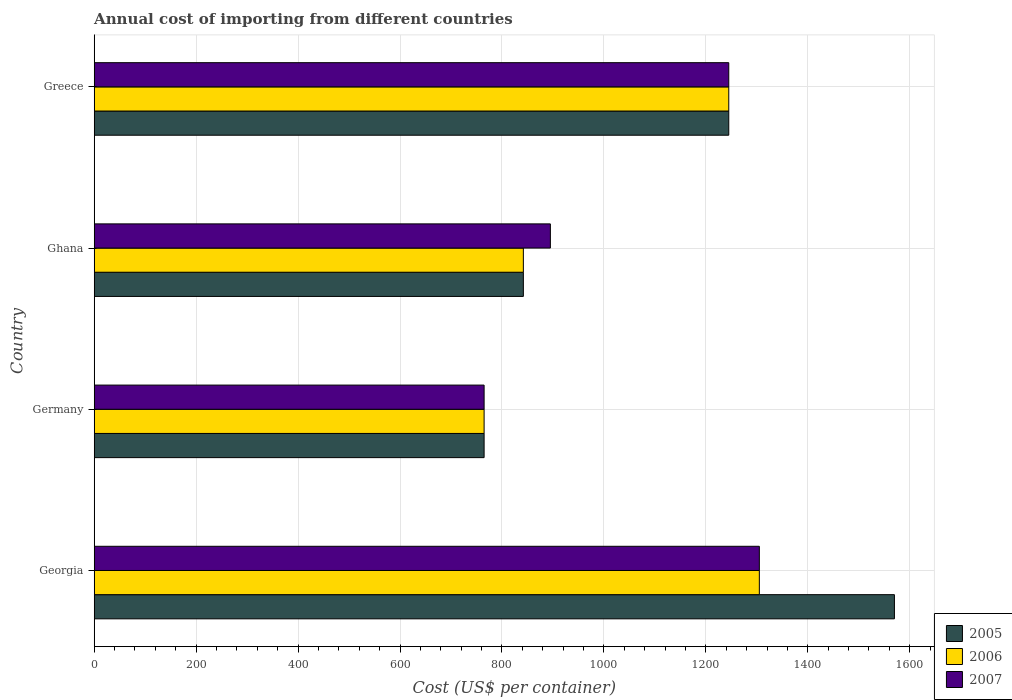How many different coloured bars are there?
Provide a short and direct response. 3. Are the number of bars per tick equal to the number of legend labels?
Give a very brief answer. Yes. Are the number of bars on each tick of the Y-axis equal?
Make the answer very short. Yes. How many bars are there on the 2nd tick from the top?
Offer a terse response. 3. How many bars are there on the 2nd tick from the bottom?
Your answer should be very brief. 3. What is the label of the 2nd group of bars from the top?
Your answer should be very brief. Ghana. In how many cases, is the number of bars for a given country not equal to the number of legend labels?
Your response must be concise. 0. What is the total annual cost of importing in 2007 in Georgia?
Provide a short and direct response. 1305. Across all countries, what is the maximum total annual cost of importing in 2006?
Offer a terse response. 1305. Across all countries, what is the minimum total annual cost of importing in 2006?
Your answer should be very brief. 765. In which country was the total annual cost of importing in 2005 maximum?
Your answer should be very brief. Georgia. What is the total total annual cost of importing in 2007 in the graph?
Ensure brevity in your answer.  4210. What is the difference between the total annual cost of importing in 2006 in Germany and that in Ghana?
Ensure brevity in your answer.  -77. What is the difference between the total annual cost of importing in 2007 in Greece and the total annual cost of importing in 2005 in Ghana?
Offer a terse response. 403. What is the average total annual cost of importing in 2005 per country?
Offer a very short reply. 1105.5. What is the difference between the total annual cost of importing in 2007 and total annual cost of importing in 2005 in Germany?
Offer a terse response. 0. What is the ratio of the total annual cost of importing in 2005 in Georgia to that in Ghana?
Offer a very short reply. 1.86. Is the difference between the total annual cost of importing in 2007 in Germany and Ghana greater than the difference between the total annual cost of importing in 2005 in Germany and Ghana?
Provide a succinct answer. No. What is the difference between the highest and the lowest total annual cost of importing in 2007?
Provide a succinct answer. 540. In how many countries, is the total annual cost of importing in 2007 greater than the average total annual cost of importing in 2007 taken over all countries?
Your answer should be very brief. 2. Is it the case that in every country, the sum of the total annual cost of importing in 2007 and total annual cost of importing in 2005 is greater than the total annual cost of importing in 2006?
Offer a terse response. Yes. Are all the bars in the graph horizontal?
Your answer should be very brief. Yes. Are the values on the major ticks of X-axis written in scientific E-notation?
Make the answer very short. No. Does the graph contain grids?
Your response must be concise. Yes. Where does the legend appear in the graph?
Provide a short and direct response. Bottom right. What is the title of the graph?
Your answer should be very brief. Annual cost of importing from different countries. What is the label or title of the X-axis?
Offer a terse response. Cost (US$ per container). What is the Cost (US$ per container) of 2005 in Georgia?
Give a very brief answer. 1570. What is the Cost (US$ per container) in 2006 in Georgia?
Ensure brevity in your answer.  1305. What is the Cost (US$ per container) of 2007 in Georgia?
Provide a short and direct response. 1305. What is the Cost (US$ per container) of 2005 in Germany?
Ensure brevity in your answer.  765. What is the Cost (US$ per container) in 2006 in Germany?
Give a very brief answer. 765. What is the Cost (US$ per container) in 2007 in Germany?
Your response must be concise. 765. What is the Cost (US$ per container) in 2005 in Ghana?
Make the answer very short. 842. What is the Cost (US$ per container) in 2006 in Ghana?
Your answer should be very brief. 842. What is the Cost (US$ per container) in 2007 in Ghana?
Make the answer very short. 895. What is the Cost (US$ per container) of 2005 in Greece?
Provide a short and direct response. 1245. What is the Cost (US$ per container) of 2006 in Greece?
Give a very brief answer. 1245. What is the Cost (US$ per container) in 2007 in Greece?
Keep it short and to the point. 1245. Across all countries, what is the maximum Cost (US$ per container) in 2005?
Offer a terse response. 1570. Across all countries, what is the maximum Cost (US$ per container) in 2006?
Your answer should be very brief. 1305. Across all countries, what is the maximum Cost (US$ per container) of 2007?
Offer a very short reply. 1305. Across all countries, what is the minimum Cost (US$ per container) in 2005?
Give a very brief answer. 765. Across all countries, what is the minimum Cost (US$ per container) in 2006?
Provide a short and direct response. 765. Across all countries, what is the minimum Cost (US$ per container) in 2007?
Ensure brevity in your answer.  765. What is the total Cost (US$ per container) in 2005 in the graph?
Your answer should be very brief. 4422. What is the total Cost (US$ per container) of 2006 in the graph?
Give a very brief answer. 4157. What is the total Cost (US$ per container) in 2007 in the graph?
Offer a terse response. 4210. What is the difference between the Cost (US$ per container) of 2005 in Georgia and that in Germany?
Offer a very short reply. 805. What is the difference between the Cost (US$ per container) of 2006 in Georgia and that in Germany?
Make the answer very short. 540. What is the difference between the Cost (US$ per container) in 2007 in Georgia and that in Germany?
Give a very brief answer. 540. What is the difference between the Cost (US$ per container) in 2005 in Georgia and that in Ghana?
Your response must be concise. 728. What is the difference between the Cost (US$ per container) in 2006 in Georgia and that in Ghana?
Keep it short and to the point. 463. What is the difference between the Cost (US$ per container) in 2007 in Georgia and that in Ghana?
Provide a short and direct response. 410. What is the difference between the Cost (US$ per container) of 2005 in Georgia and that in Greece?
Your answer should be very brief. 325. What is the difference between the Cost (US$ per container) in 2005 in Germany and that in Ghana?
Ensure brevity in your answer.  -77. What is the difference between the Cost (US$ per container) of 2006 in Germany and that in Ghana?
Provide a succinct answer. -77. What is the difference between the Cost (US$ per container) in 2007 in Germany and that in Ghana?
Ensure brevity in your answer.  -130. What is the difference between the Cost (US$ per container) of 2005 in Germany and that in Greece?
Your response must be concise. -480. What is the difference between the Cost (US$ per container) of 2006 in Germany and that in Greece?
Your response must be concise. -480. What is the difference between the Cost (US$ per container) in 2007 in Germany and that in Greece?
Offer a terse response. -480. What is the difference between the Cost (US$ per container) in 2005 in Ghana and that in Greece?
Give a very brief answer. -403. What is the difference between the Cost (US$ per container) in 2006 in Ghana and that in Greece?
Give a very brief answer. -403. What is the difference between the Cost (US$ per container) of 2007 in Ghana and that in Greece?
Provide a short and direct response. -350. What is the difference between the Cost (US$ per container) of 2005 in Georgia and the Cost (US$ per container) of 2006 in Germany?
Your answer should be very brief. 805. What is the difference between the Cost (US$ per container) of 2005 in Georgia and the Cost (US$ per container) of 2007 in Germany?
Offer a terse response. 805. What is the difference between the Cost (US$ per container) of 2006 in Georgia and the Cost (US$ per container) of 2007 in Germany?
Provide a short and direct response. 540. What is the difference between the Cost (US$ per container) of 2005 in Georgia and the Cost (US$ per container) of 2006 in Ghana?
Offer a terse response. 728. What is the difference between the Cost (US$ per container) of 2005 in Georgia and the Cost (US$ per container) of 2007 in Ghana?
Your answer should be very brief. 675. What is the difference between the Cost (US$ per container) of 2006 in Georgia and the Cost (US$ per container) of 2007 in Ghana?
Your response must be concise. 410. What is the difference between the Cost (US$ per container) of 2005 in Georgia and the Cost (US$ per container) of 2006 in Greece?
Your response must be concise. 325. What is the difference between the Cost (US$ per container) of 2005 in Georgia and the Cost (US$ per container) of 2007 in Greece?
Your answer should be very brief. 325. What is the difference between the Cost (US$ per container) in 2005 in Germany and the Cost (US$ per container) in 2006 in Ghana?
Ensure brevity in your answer.  -77. What is the difference between the Cost (US$ per container) of 2005 in Germany and the Cost (US$ per container) of 2007 in Ghana?
Provide a short and direct response. -130. What is the difference between the Cost (US$ per container) in 2006 in Germany and the Cost (US$ per container) in 2007 in Ghana?
Ensure brevity in your answer.  -130. What is the difference between the Cost (US$ per container) in 2005 in Germany and the Cost (US$ per container) in 2006 in Greece?
Offer a terse response. -480. What is the difference between the Cost (US$ per container) in 2005 in Germany and the Cost (US$ per container) in 2007 in Greece?
Your answer should be compact. -480. What is the difference between the Cost (US$ per container) of 2006 in Germany and the Cost (US$ per container) of 2007 in Greece?
Keep it short and to the point. -480. What is the difference between the Cost (US$ per container) in 2005 in Ghana and the Cost (US$ per container) in 2006 in Greece?
Offer a very short reply. -403. What is the difference between the Cost (US$ per container) in 2005 in Ghana and the Cost (US$ per container) in 2007 in Greece?
Offer a terse response. -403. What is the difference between the Cost (US$ per container) of 2006 in Ghana and the Cost (US$ per container) of 2007 in Greece?
Offer a terse response. -403. What is the average Cost (US$ per container) in 2005 per country?
Keep it short and to the point. 1105.5. What is the average Cost (US$ per container) in 2006 per country?
Keep it short and to the point. 1039.25. What is the average Cost (US$ per container) of 2007 per country?
Provide a short and direct response. 1052.5. What is the difference between the Cost (US$ per container) in 2005 and Cost (US$ per container) in 2006 in Georgia?
Offer a very short reply. 265. What is the difference between the Cost (US$ per container) of 2005 and Cost (US$ per container) of 2007 in Georgia?
Ensure brevity in your answer.  265. What is the difference between the Cost (US$ per container) in 2006 and Cost (US$ per container) in 2007 in Georgia?
Your response must be concise. 0. What is the difference between the Cost (US$ per container) in 2005 and Cost (US$ per container) in 2006 in Germany?
Your response must be concise. 0. What is the difference between the Cost (US$ per container) of 2005 and Cost (US$ per container) of 2007 in Germany?
Make the answer very short. 0. What is the difference between the Cost (US$ per container) in 2006 and Cost (US$ per container) in 2007 in Germany?
Provide a short and direct response. 0. What is the difference between the Cost (US$ per container) in 2005 and Cost (US$ per container) in 2007 in Ghana?
Offer a very short reply. -53. What is the difference between the Cost (US$ per container) of 2006 and Cost (US$ per container) of 2007 in Ghana?
Make the answer very short. -53. What is the difference between the Cost (US$ per container) in 2005 and Cost (US$ per container) in 2006 in Greece?
Your response must be concise. 0. What is the difference between the Cost (US$ per container) in 2005 and Cost (US$ per container) in 2007 in Greece?
Ensure brevity in your answer.  0. What is the ratio of the Cost (US$ per container) of 2005 in Georgia to that in Germany?
Make the answer very short. 2.05. What is the ratio of the Cost (US$ per container) in 2006 in Georgia to that in Germany?
Keep it short and to the point. 1.71. What is the ratio of the Cost (US$ per container) of 2007 in Georgia to that in Germany?
Keep it short and to the point. 1.71. What is the ratio of the Cost (US$ per container) of 2005 in Georgia to that in Ghana?
Offer a terse response. 1.86. What is the ratio of the Cost (US$ per container) in 2006 in Georgia to that in Ghana?
Your response must be concise. 1.55. What is the ratio of the Cost (US$ per container) of 2007 in Georgia to that in Ghana?
Provide a short and direct response. 1.46. What is the ratio of the Cost (US$ per container) in 2005 in Georgia to that in Greece?
Your response must be concise. 1.26. What is the ratio of the Cost (US$ per container) in 2006 in Georgia to that in Greece?
Keep it short and to the point. 1.05. What is the ratio of the Cost (US$ per container) in 2007 in Georgia to that in Greece?
Ensure brevity in your answer.  1.05. What is the ratio of the Cost (US$ per container) in 2005 in Germany to that in Ghana?
Offer a terse response. 0.91. What is the ratio of the Cost (US$ per container) of 2006 in Germany to that in Ghana?
Offer a very short reply. 0.91. What is the ratio of the Cost (US$ per container) of 2007 in Germany to that in Ghana?
Offer a terse response. 0.85. What is the ratio of the Cost (US$ per container) in 2005 in Germany to that in Greece?
Provide a succinct answer. 0.61. What is the ratio of the Cost (US$ per container) of 2006 in Germany to that in Greece?
Your answer should be very brief. 0.61. What is the ratio of the Cost (US$ per container) in 2007 in Germany to that in Greece?
Ensure brevity in your answer.  0.61. What is the ratio of the Cost (US$ per container) in 2005 in Ghana to that in Greece?
Your response must be concise. 0.68. What is the ratio of the Cost (US$ per container) of 2006 in Ghana to that in Greece?
Offer a very short reply. 0.68. What is the ratio of the Cost (US$ per container) of 2007 in Ghana to that in Greece?
Your answer should be compact. 0.72. What is the difference between the highest and the second highest Cost (US$ per container) of 2005?
Offer a terse response. 325. What is the difference between the highest and the lowest Cost (US$ per container) in 2005?
Make the answer very short. 805. What is the difference between the highest and the lowest Cost (US$ per container) in 2006?
Your answer should be compact. 540. What is the difference between the highest and the lowest Cost (US$ per container) in 2007?
Give a very brief answer. 540. 